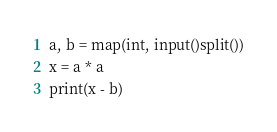Convert code to text. <code><loc_0><loc_0><loc_500><loc_500><_Python_>a, b = map(int, input()split())
x = a * a
print(x - b)</code> 